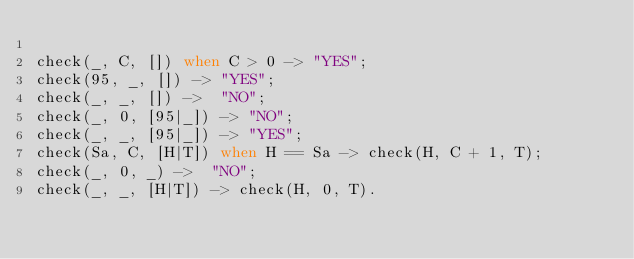Convert code to text. <code><loc_0><loc_0><loc_500><loc_500><_Erlang_>
check(_, C, []) when C > 0 -> "YES";
check(95, _, []) -> "YES";
check(_, _, []) ->  "NO";
check(_, 0, [95|_]) -> "NO";
check(_, _, [95|_]) -> "YES";
check(Sa, C, [H|T]) when H == Sa -> check(H, C + 1, T);
check(_, 0, _) ->  "NO";
check(_, _, [H|T]) -> check(H, 0, T).

</code> 